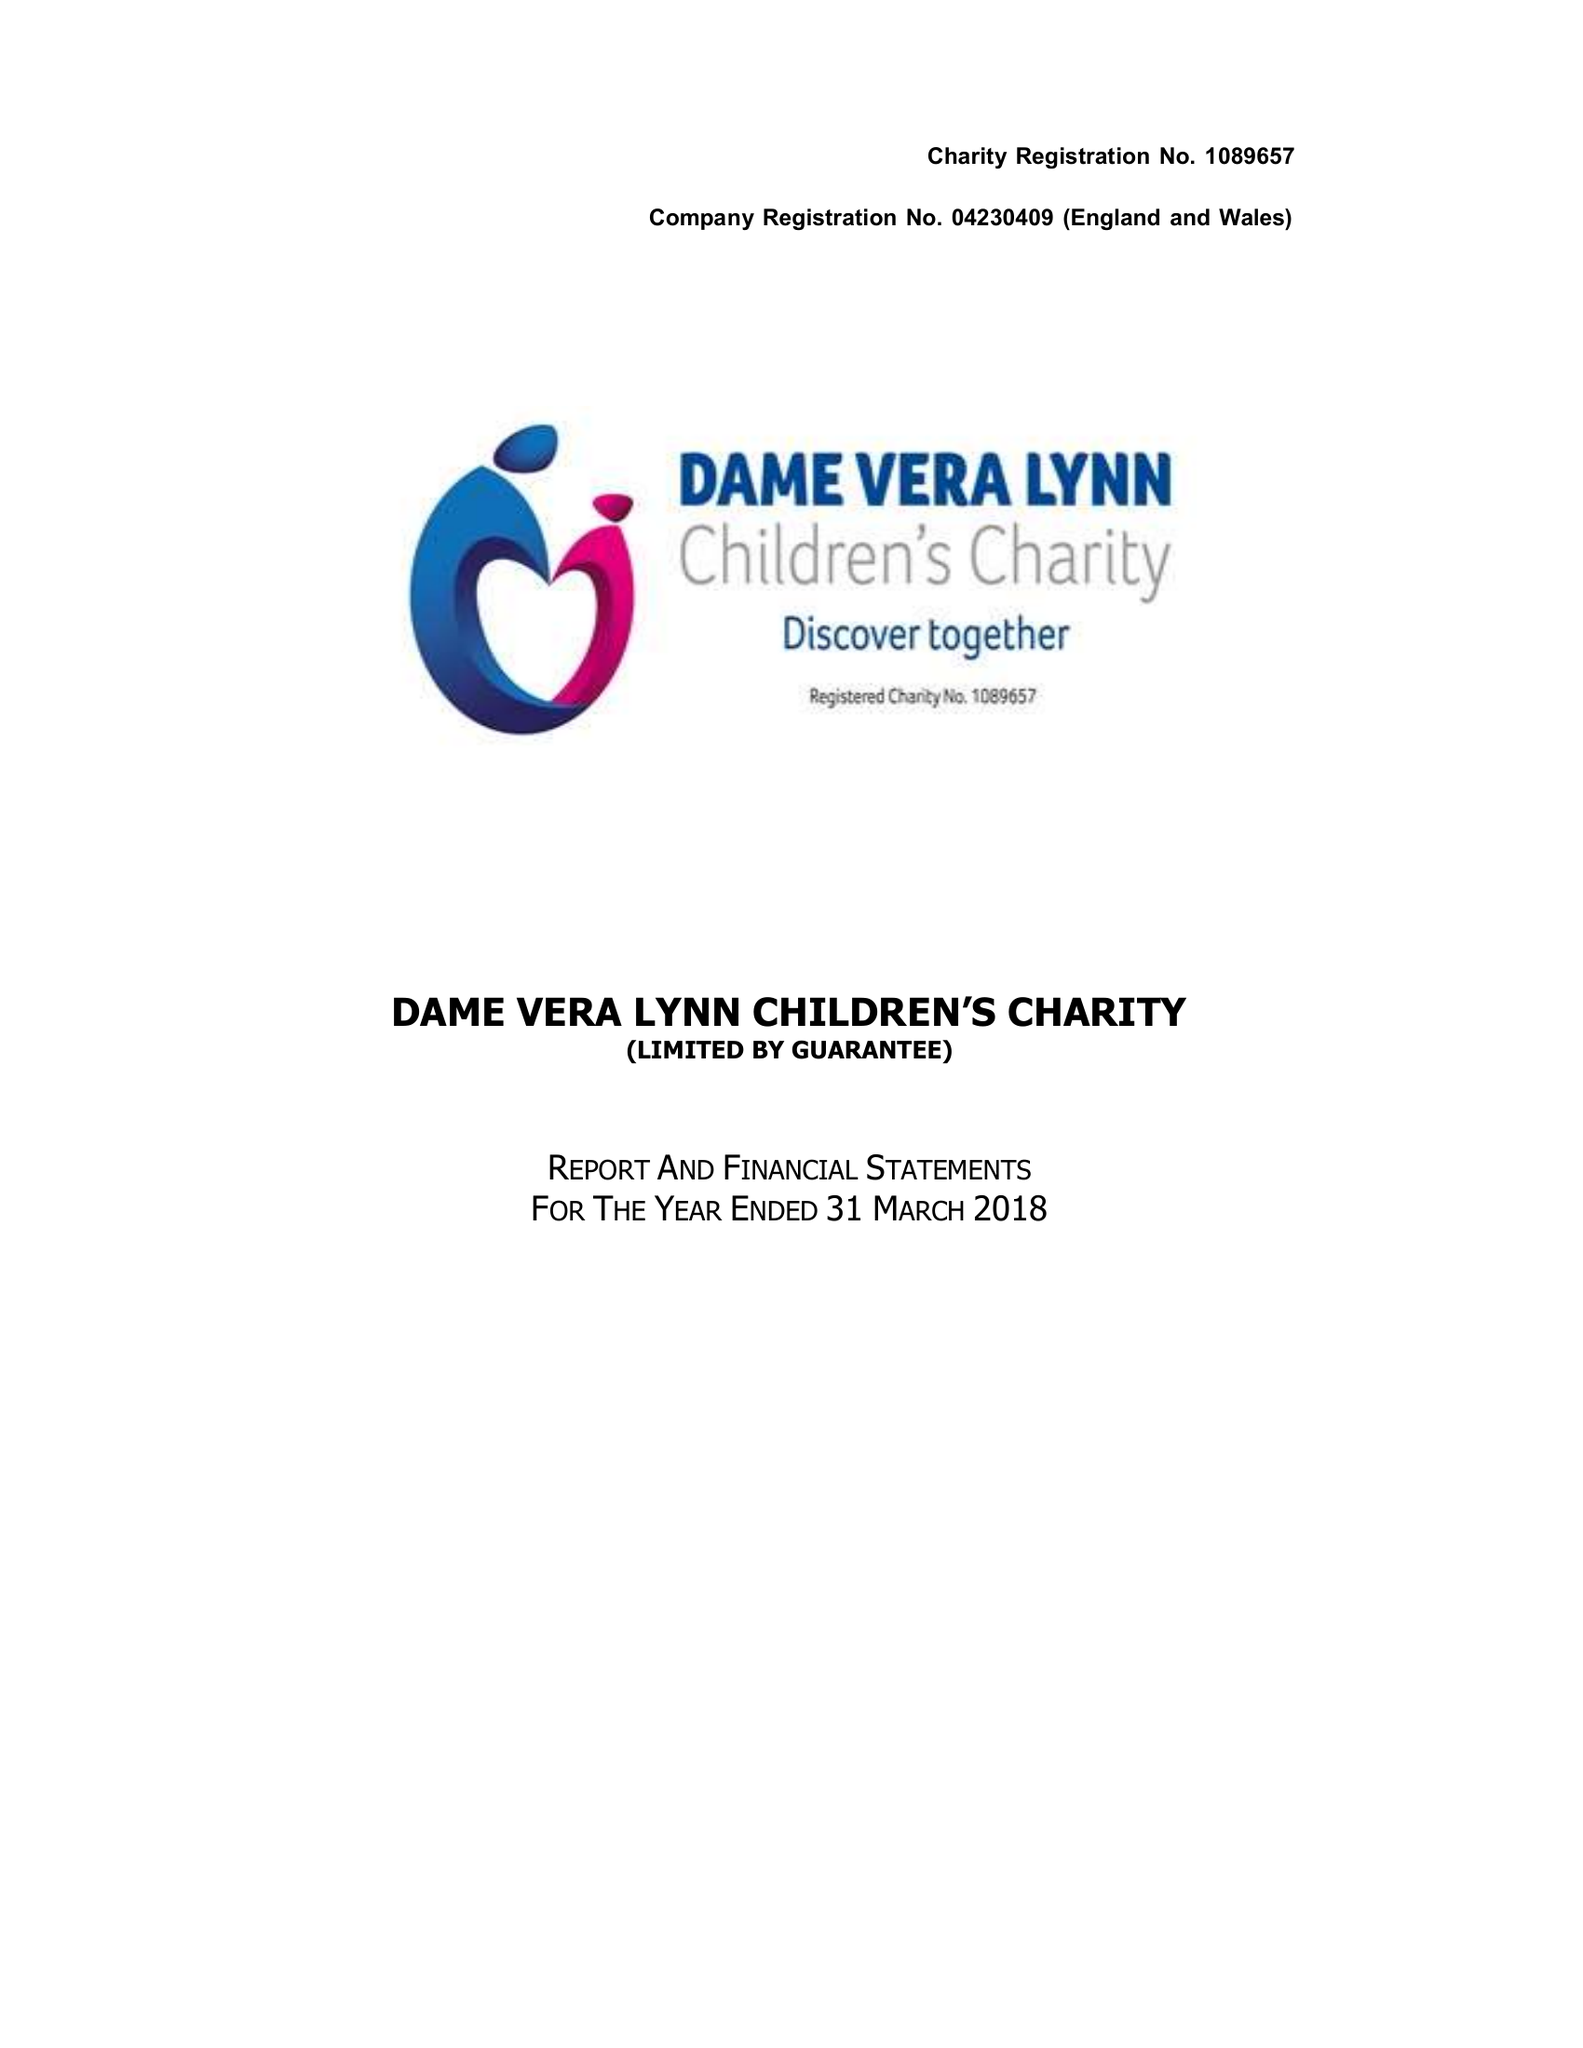What is the value for the address__postcode?
Answer the question using a single word or phrase. RH17 5JF 